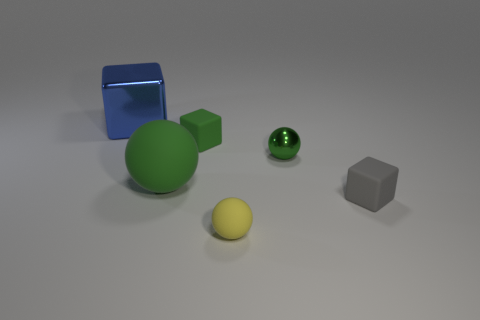What number of big matte balls have the same color as the small shiny ball?
Provide a short and direct response. 1. The other object that is made of the same material as the big blue object is what color?
Make the answer very short. Green. Is there a yellow rubber object of the same size as the blue metallic object?
Keep it short and to the point. No. Are there more metal things that are on the right side of the small yellow sphere than small green metal things that are behind the large metallic thing?
Ensure brevity in your answer.  Yes. Does the blue object behind the tiny gray rubber object have the same material as the big object to the right of the big metallic cube?
Make the answer very short. No. There is a gray rubber thing that is the same size as the green cube; what is its shape?
Keep it short and to the point. Cube. Is there a big green object of the same shape as the yellow rubber object?
Give a very brief answer. Yes. Does the metallic object to the right of the blue shiny thing have the same color as the small matte object that is behind the big sphere?
Give a very brief answer. Yes. Are there any matte things in front of the tiny gray matte block?
Keep it short and to the point. Yes. What is the material of the block that is on the left side of the small metallic thing and in front of the big cube?
Provide a short and direct response. Rubber. 